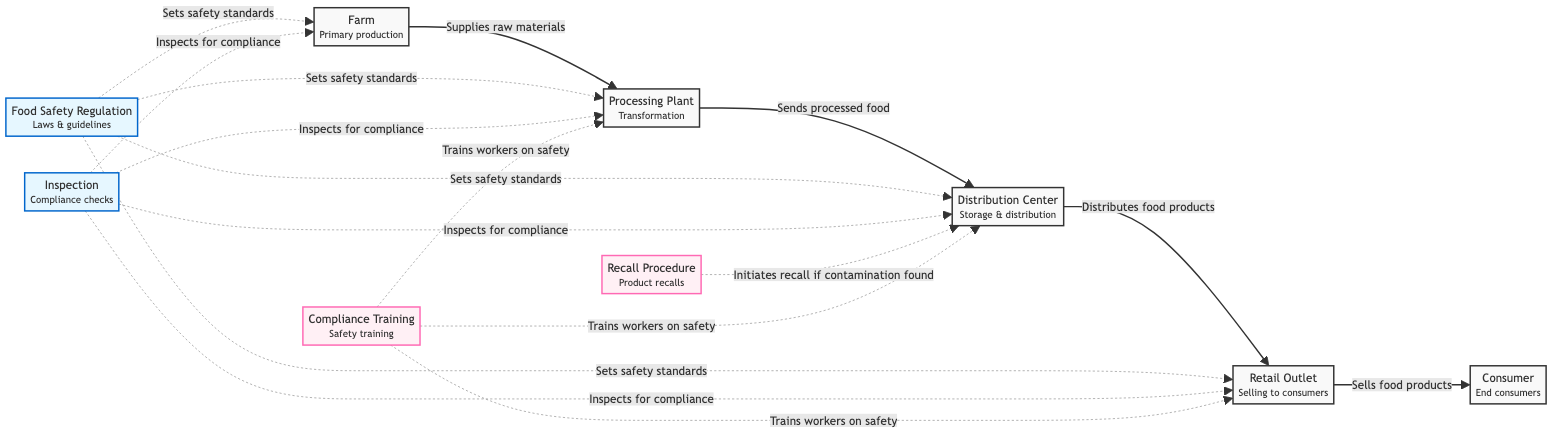What is the first node in the food chain? The diagram shows the flow starting from the "Farm," which is the first node and indicates primary production.
Answer: Farm How many main nodes are in the food chain? The diagram includes five main nodes: Farm, Processing Plant, Distribution Center, Retail Outlet, and Consumer. Counting these nodes gives a total of five.
Answer: 5 Which node is responsible for compliance checks? The "Inspection" node is indicated in the diagram as responsible for compliance checks, inspecting various points in the food chain.
Answer: Inspection What is initiated if contamination is found? The "Recall Procedure" node indicates that a recall is initiated if contamination is found, as depicted in the arrow direction from the node.
Answer: Recall Procedure Which nodes receive compliance training according to the diagram? The nodes that receive compliance training are Processing Plant, Distribution Center, and Retail Outlet, as this is shown by the outgoing arrows from the "Compliance Training" node.
Answer: Processing Plant, Distribution Center, Retail Outlet What do food safety regulations set standards for? Food safety regulations set safety standards for the Farm, Processing Plant, Distribution Center, and Retail Outlet, as indicated by the directed arrows connecting these nodes.
Answer: Safety standards Which node directly distributes food products? The "Distribution Center" node is shown in the diagram to directly distribute food products to the Retail Outlet, as depicted by the connecting arrow.
Answer: Distribution Center What relationship does the "Processing Plant" have with the "Farm"? The "Processing Plant" receives raw materials from the "Farm," which is represented by the arrow pointed from Farm to Processing Plant indicating the supply of raw materials.
Answer: Supplies raw materials Which node is responsible for training workers on food safety? The "Compliance Training" node is responsible for training workers on safety, with outgoing connections to Processing Plant, Distribution Center, and Retail Outlet for this purpose.
Answer: Compliance Training 